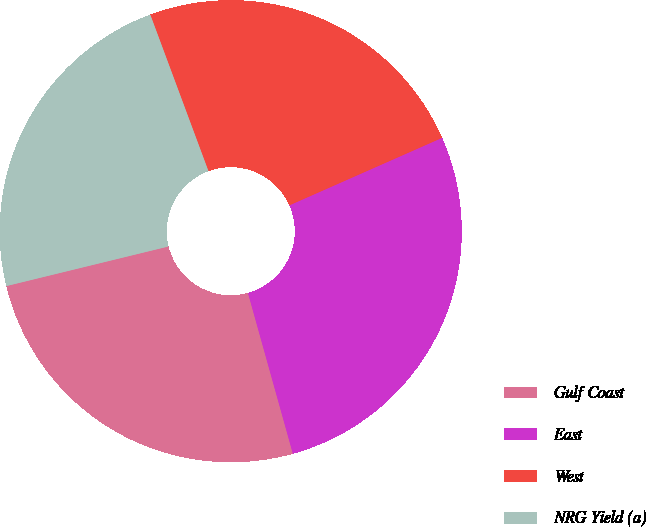<chart> <loc_0><loc_0><loc_500><loc_500><pie_chart><fcel>Gulf Coast<fcel>East<fcel>West<fcel>NRG Yield (a)<nl><fcel>25.52%<fcel>27.29%<fcel>24.04%<fcel>23.15%<nl></chart> 